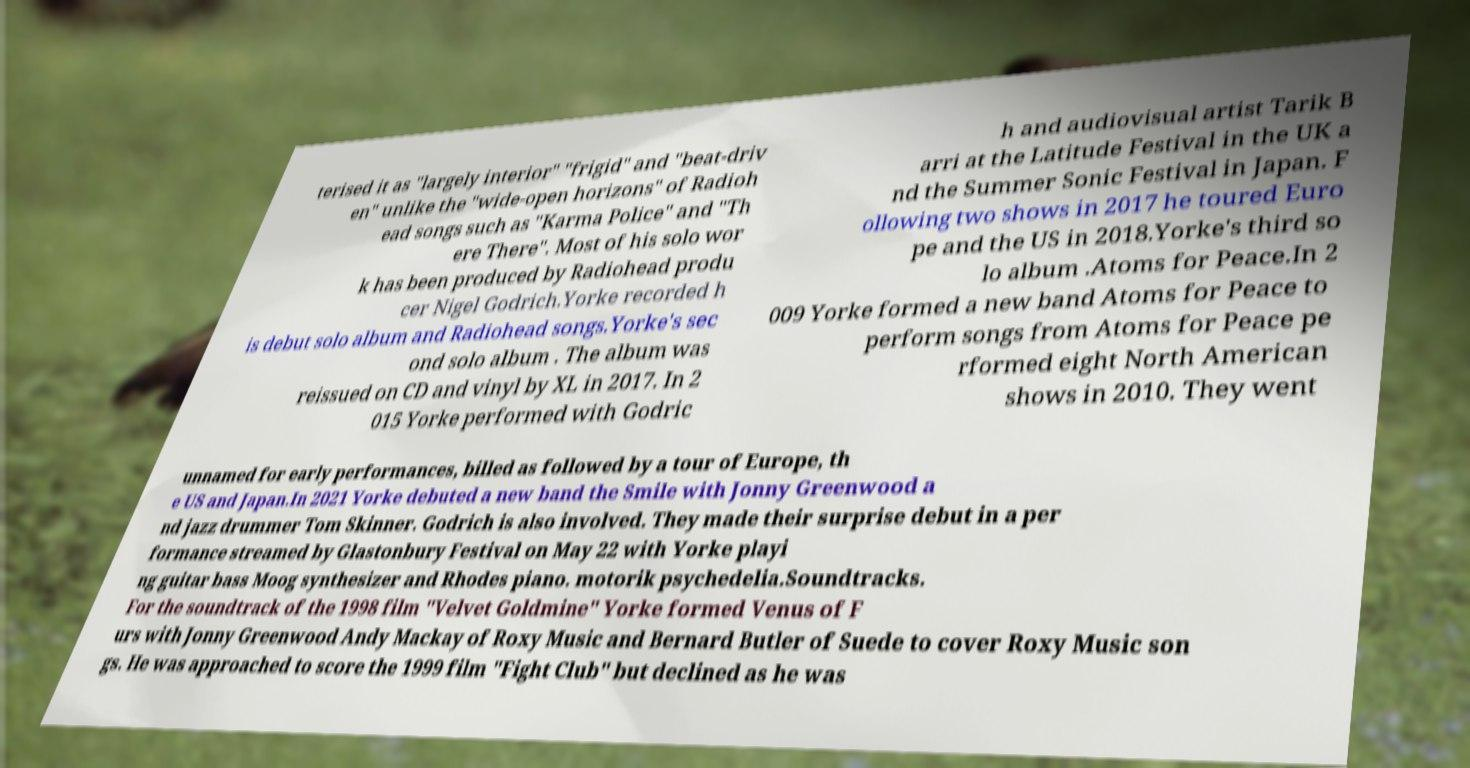What messages or text are displayed in this image? I need them in a readable, typed format. terised it as "largely interior" "frigid" and "beat-driv en" unlike the "wide-open horizons" of Radioh ead songs such as "Karma Police" and "Th ere There". Most of his solo wor k has been produced by Radiohead produ cer Nigel Godrich.Yorke recorded h is debut solo album and Radiohead songs.Yorke's sec ond solo album . The album was reissued on CD and vinyl by XL in 2017. In 2 015 Yorke performed with Godric h and audiovisual artist Tarik B arri at the Latitude Festival in the UK a nd the Summer Sonic Festival in Japan. F ollowing two shows in 2017 he toured Euro pe and the US in 2018.Yorke's third so lo album .Atoms for Peace.In 2 009 Yorke formed a new band Atoms for Peace to perform songs from Atoms for Peace pe rformed eight North American shows in 2010. They went unnamed for early performances, billed as followed by a tour of Europe, th e US and Japan.In 2021 Yorke debuted a new band the Smile with Jonny Greenwood a nd jazz drummer Tom Skinner. Godrich is also involved. They made their surprise debut in a per formance streamed by Glastonbury Festival on May 22 with Yorke playi ng guitar bass Moog synthesizer and Rhodes piano. motorik psychedelia.Soundtracks. For the soundtrack of the 1998 film "Velvet Goldmine" Yorke formed Venus of F urs with Jonny Greenwood Andy Mackay of Roxy Music and Bernard Butler of Suede to cover Roxy Music son gs. He was approached to score the 1999 film "Fight Club" but declined as he was 